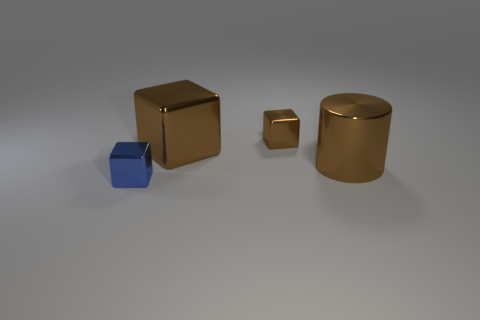There is a large thing that is the same color as the big metal cylinder; what is its shape?
Give a very brief answer. Cube. Is the color of the tiny cube that is in front of the cylinder the same as the big shiny cylinder?
Your answer should be very brief. No. What shape is the shiny object on the right side of the tiny metal cube that is behind the small blue shiny block?
Make the answer very short. Cylinder. How many objects are brown shiny things that are in front of the tiny brown object or brown metal cylinders that are behind the blue cube?
Make the answer very short. 2. There is a blue object that is made of the same material as the small brown cube; what is its shape?
Make the answer very short. Cube. Is there anything else that has the same color as the large block?
Offer a very short reply. Yes. There is a big brown object that is the same shape as the blue metal thing; what is its material?
Your response must be concise. Metal. How many other objects are there of the same size as the brown metal cylinder?
Your answer should be very brief. 1. What is the blue object made of?
Your answer should be very brief. Metal. Is the number of tiny brown objects right of the tiny brown block greater than the number of large metal things?
Give a very brief answer. No. 